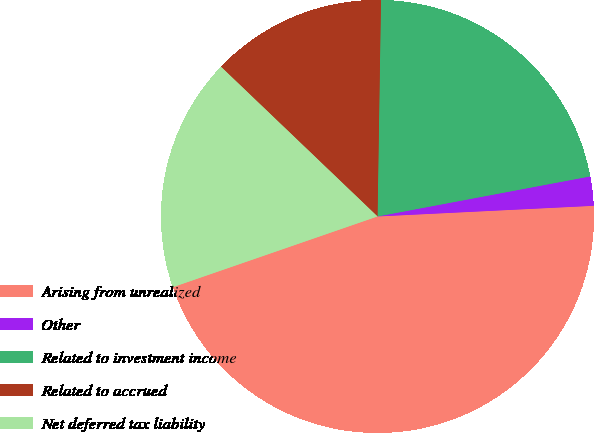Convert chart. <chart><loc_0><loc_0><loc_500><loc_500><pie_chart><fcel>Arising from unrealized<fcel>Other<fcel>Related to investment income<fcel>Related to accrued<fcel>Net deferred tax liability<nl><fcel>45.49%<fcel>2.18%<fcel>21.78%<fcel>13.11%<fcel>17.44%<nl></chart> 